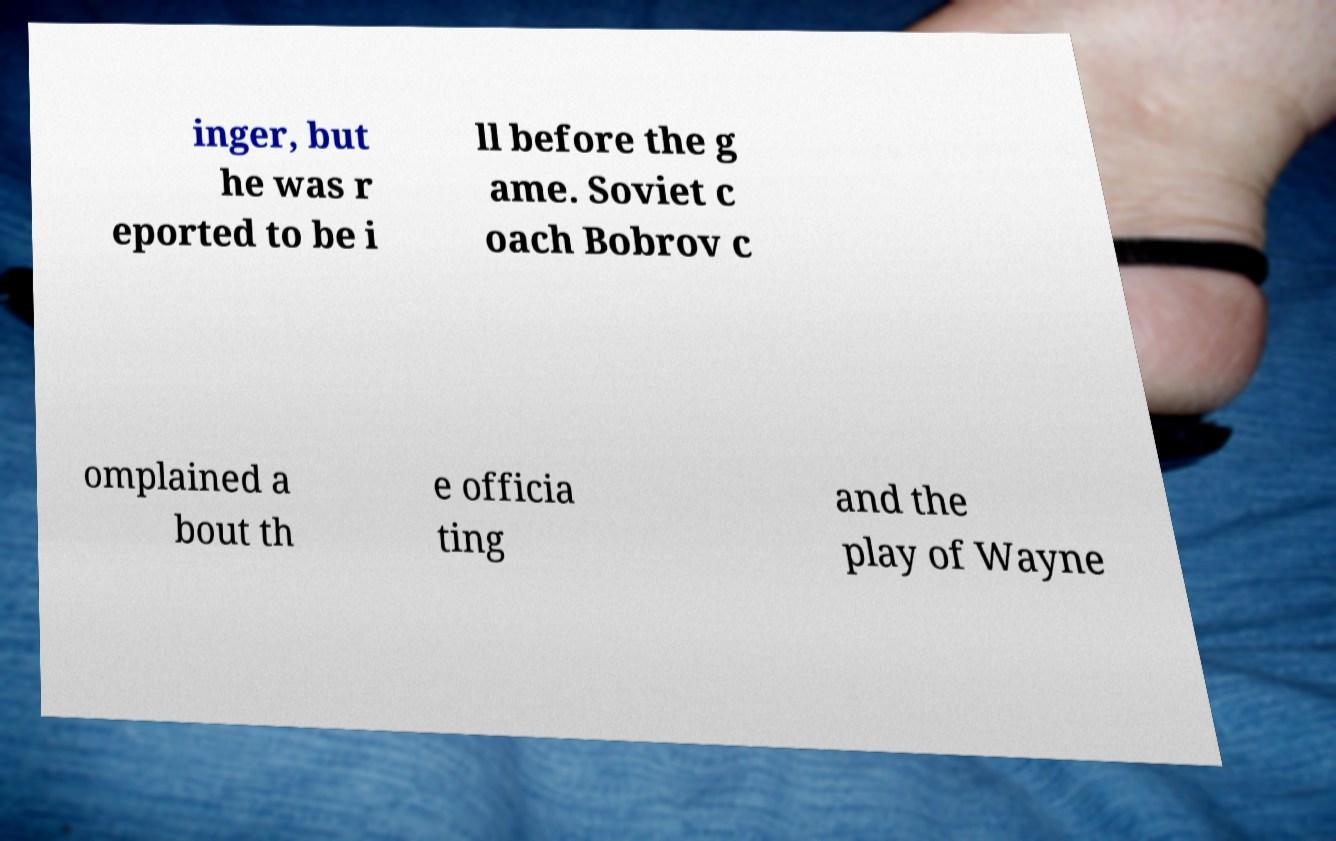Please identify and transcribe the text found in this image. inger, but he was r eported to be i ll before the g ame. Soviet c oach Bobrov c omplained a bout th e officia ting and the play of Wayne 